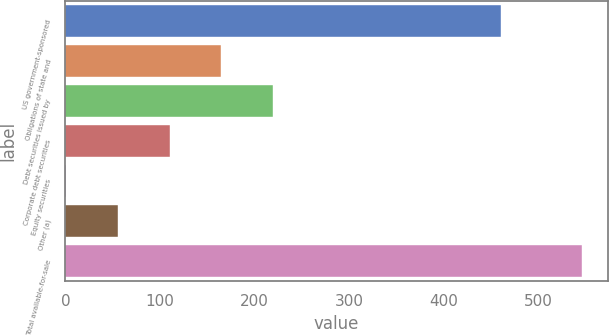Convert chart. <chart><loc_0><loc_0><loc_500><loc_500><bar_chart><fcel>US government-sponsored<fcel>Obligations of state and<fcel>Debt securities issued by<fcel>Corporate debt securities<fcel>Equity securities<fcel>Other (a)<fcel>Total available-for-sale<nl><fcel>460<fcel>164.5<fcel>219<fcel>110<fcel>1<fcel>55.5<fcel>546<nl></chart> 